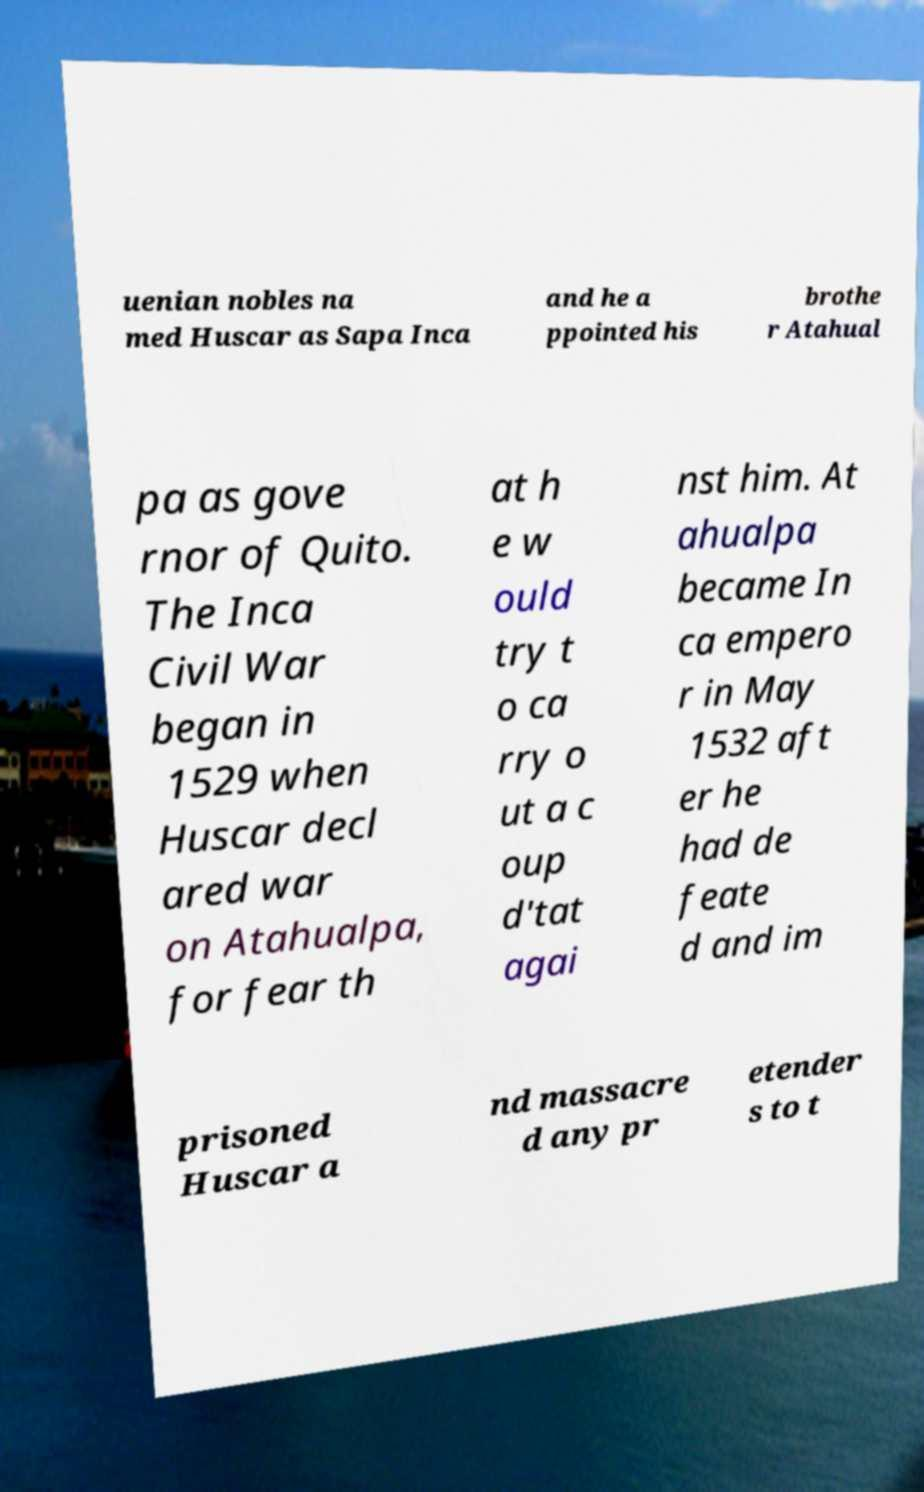Please identify and transcribe the text found in this image. uenian nobles na med Huscar as Sapa Inca and he a ppointed his brothe r Atahual pa as gove rnor of Quito. The Inca Civil War began in 1529 when Huscar decl ared war on Atahualpa, for fear th at h e w ould try t o ca rry o ut a c oup d'tat agai nst him. At ahualpa became In ca empero r in May 1532 aft er he had de feate d and im prisoned Huscar a nd massacre d any pr etender s to t 